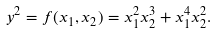<formula> <loc_0><loc_0><loc_500><loc_500>y ^ { 2 } = f ( x _ { 1 } , x _ { 2 } ) = x _ { 1 } ^ { 2 } x _ { 2 } ^ { 3 } + x _ { 1 } ^ { 4 } x _ { 2 } ^ { 2 } .</formula> 